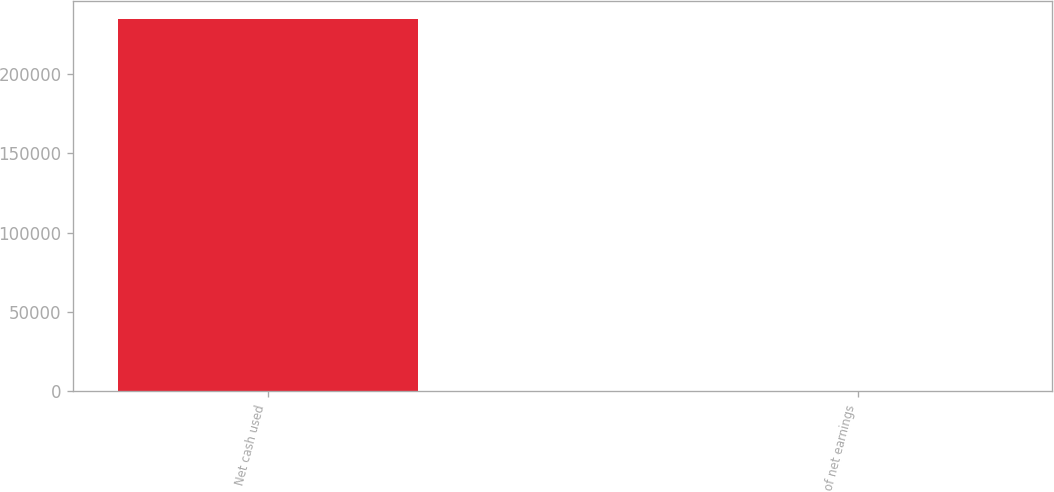<chart> <loc_0><loc_0><loc_500><loc_500><bar_chart><fcel>Net cash used<fcel>of net earnings<nl><fcel>234443<fcel>52.3<nl></chart> 